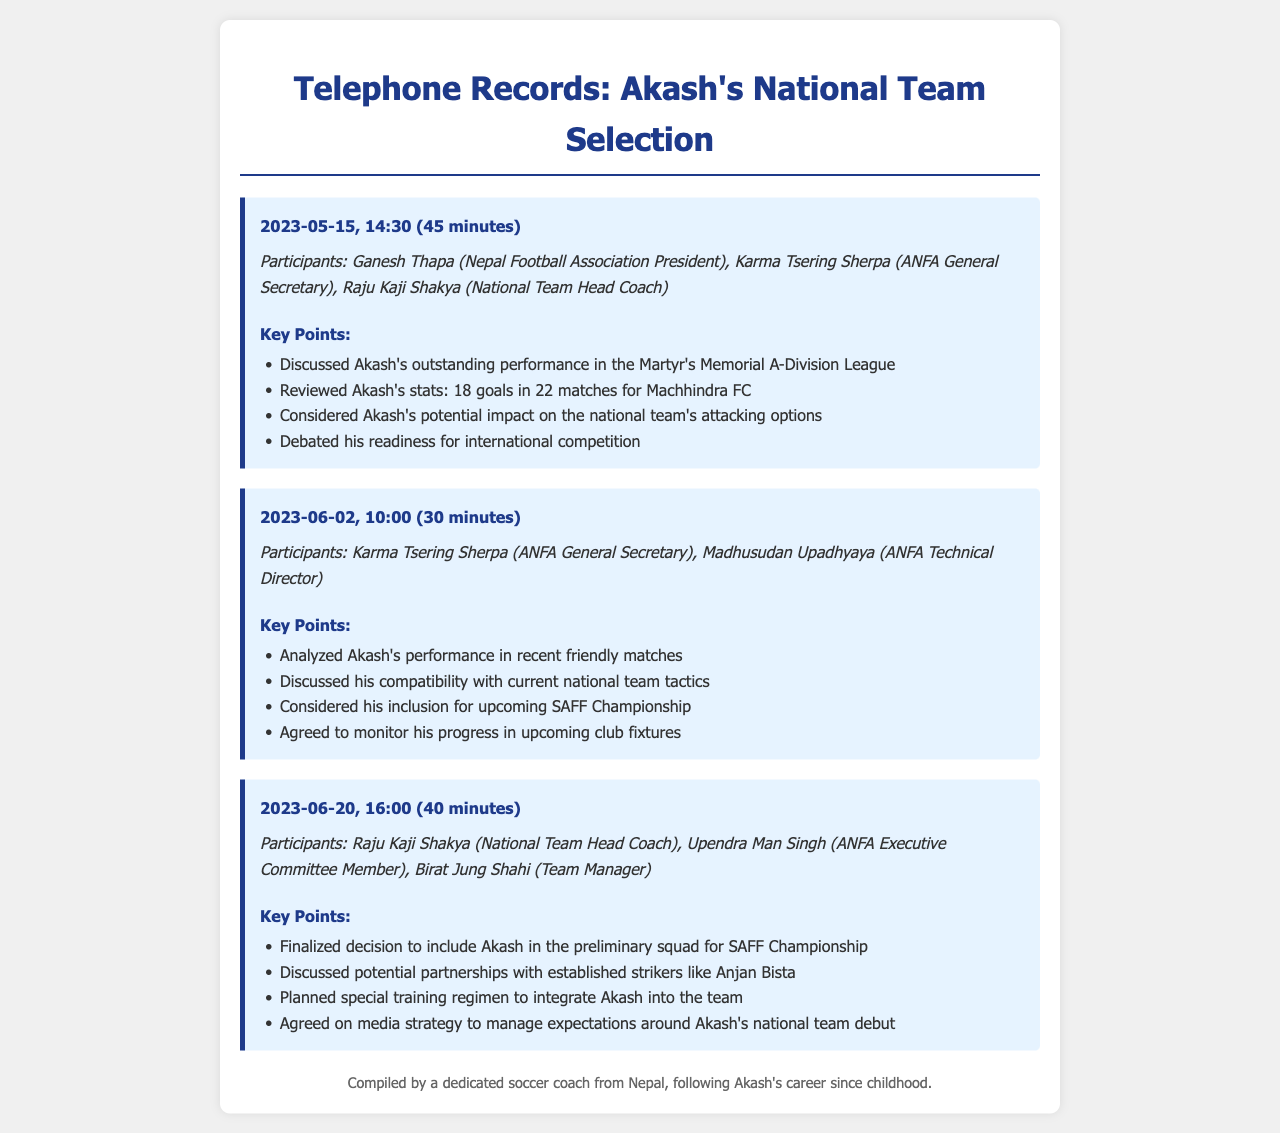What date was the first call held? The first conference call was held on May 15, 2023.
Answer: May 15, 2023 How many goals did Akash score in the league? Akash scored 18 goals in 22 matches for Machhindra FC.
Answer: 18 goals Who participated in the second call? The second call included Karma Tsering Sherpa and Madhusudan Upadhyaya.
Answer: Karma Tsering Sherpa, Madhusudan Upadhyaya What was the main topic of the third call? The main topic of the third call was finalizing Akash's inclusion in the preliminary squad for the SAFF Championship.
Answer: Inclusion in the preliminary squad What strategy was agreed upon regarding Akash's media presence? They agreed on a media strategy to manage expectations around Akash's national team debut.
Answer: Media strategy to manage expectations How long did the final call last? The final conference call lasted 40 minutes.
Answer: 40 minutes What was the key performance reviewed in the first call? Akash's outstanding performance in the Martyr's Memorial A-Division League was reviewed.
Answer: Outstanding performance in the Martyr's Memorial A-Division League Which event did they consider Akash for inclusion in? They considered including Akash for the upcoming SAFF Championship.
Answer: SAFF Championship What athletic partnership was discussed in the final call? The potential partnerships with established strikers like Anjan Bista were discussed.
Answer: Partnerships with established strikers like Anjan Bista 